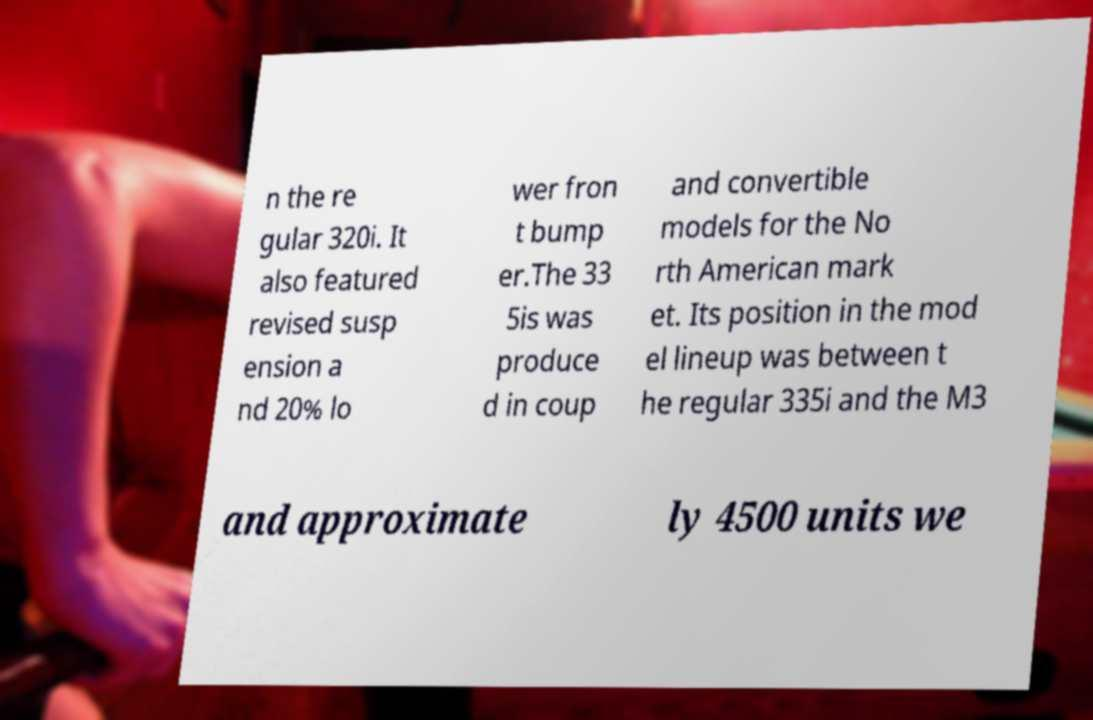What messages or text are displayed in this image? I need them in a readable, typed format. n the re gular 320i. It also featured revised susp ension a nd 20% lo wer fron t bump er.The 33 5is was produce d in coup and convertible models for the No rth American mark et. Its position in the mod el lineup was between t he regular 335i and the M3 and approximate ly 4500 units we 